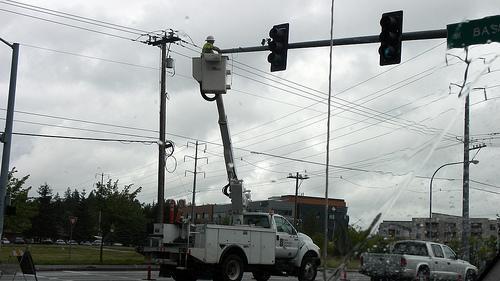How many men are there?
Give a very brief answer. 1. 